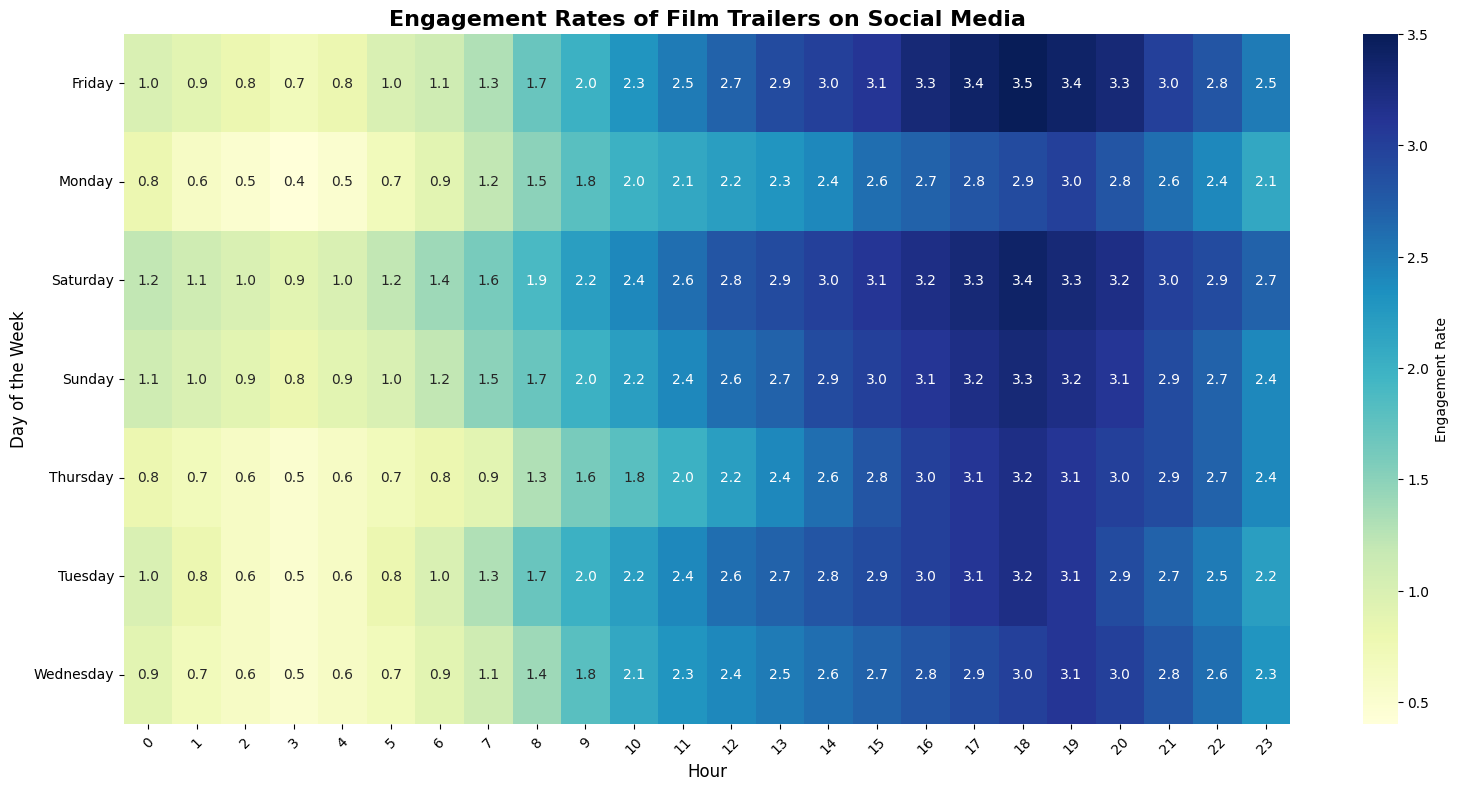Which day has the highest average engagement rate? To find the highest average engagement rate, calculate the average for each day by summing all engagement rates for the day and dividing by the number of hours (24). Compare the averages to identify the highest.
Answer: Friday What time of day tends to have the lowest engagement rate overall? To determine the hour with the lowest engagement rate on average, look at the engagement rates for each hour across all days. Identify the hour with the consistently lowest values.
Answer: 3 AM Which day shows the most significant increase in engagement rate from early morning (6 AM) to late afternoon (6 PM)? Assess the difference between the engagement rate at 6 AM and 6 PM for each day. The day with the largest positive difference has the most significant increase.
Answer: Saturday Is there any day where the engagement rate consistently decreases in the late evening hours (from 8 PM to 12 AM)? Examine the engagement rates between 8 PM and 12 AM for each day. Identify if there is a day where the engagement rate consistently decreases during these hours.
Answer: Monday On which day is the engagement rate at 9 AM the highest? Compare the engagement rates at 9 AM across all days to find the highest rate.
Answer: Friday How does the engagement rate at 1 PM on Tuesday compare to 1 PM on Sunday? Compare the engagement rates at 1 PM for both Tuesday and Sunday by directly reading the values off the heatmap.
Answer: Tuesday is higher What is the range of engagement rates for Wednesday? Find the minimum and maximum engagement rates for Wednesday and subtract the minimum from the maximum to get the range.
Answer: 3.1 - 0.5 = 2.6 Is there a significant difference in engagement rates between weekdays and weekends during the mid-afternoon hours (3 PM - 5 PM)? For this, compare the engagement rates from 3 PM to 5 PM on weekdays and weekends. Calculate the averages for both groups and compare them to see if there's a significant difference.
Answer: Yes, weekends are generally higher Which two consecutive hours have the largest increase in engagement rate on any given day? Identify the two consecutive hours with the greatest difference in engagement rates by checking the difference for each pair of consecutive hours across all days.
Answer: Between 6 AM and 7 AM on Monday Do weekdays or weekends generally have higher engagement rates in the early morning (5 AM - 7 AM)? Calculate the average engagement rates from 5 AM to 7 AM for weekdays and weekends separately. Compare these two averages.
Answer: Weekdays 